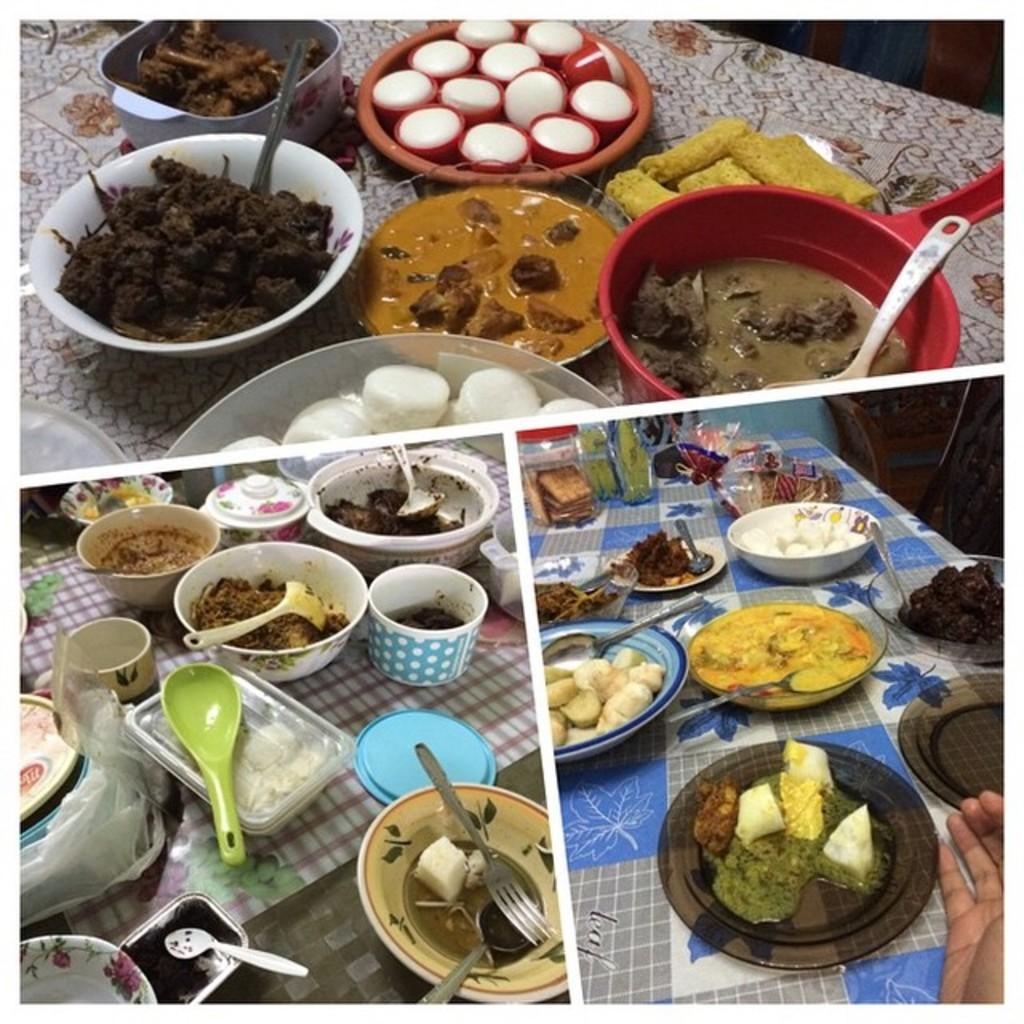What type of artwork is depicted in the image? The image is a collage. What can be seen in the collage? There are different kinds of food items in the image. How are the food items presented in the collage? The food items are placed in serving dishes. What tools are available for eating the food in the image? Cutlery is visible in the image. What type of dishware is present in the image? Crockery is present in the image. Can you tell me how many vessels are floating in the quicksand in the image? There is no quicksand or vessels present in the image; it features a collage of food items placed in serving dishes with cutlery and crockery. 